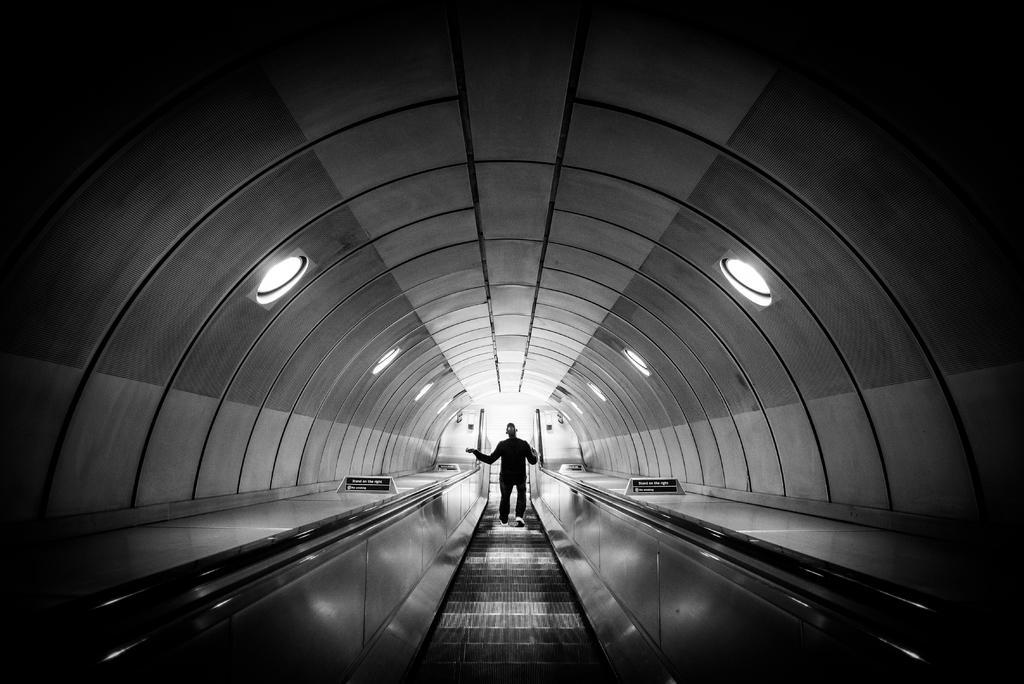Describe this image in one or two sentences. In this image I can see an escalator, on the escalator I can see a person , at the top I can see the roof and on the roof I can see lights attached to the roof. 